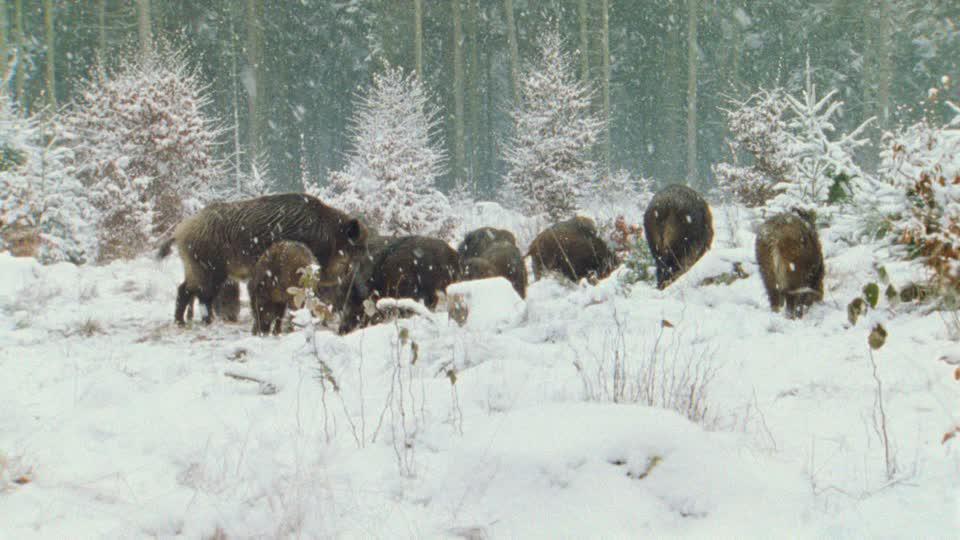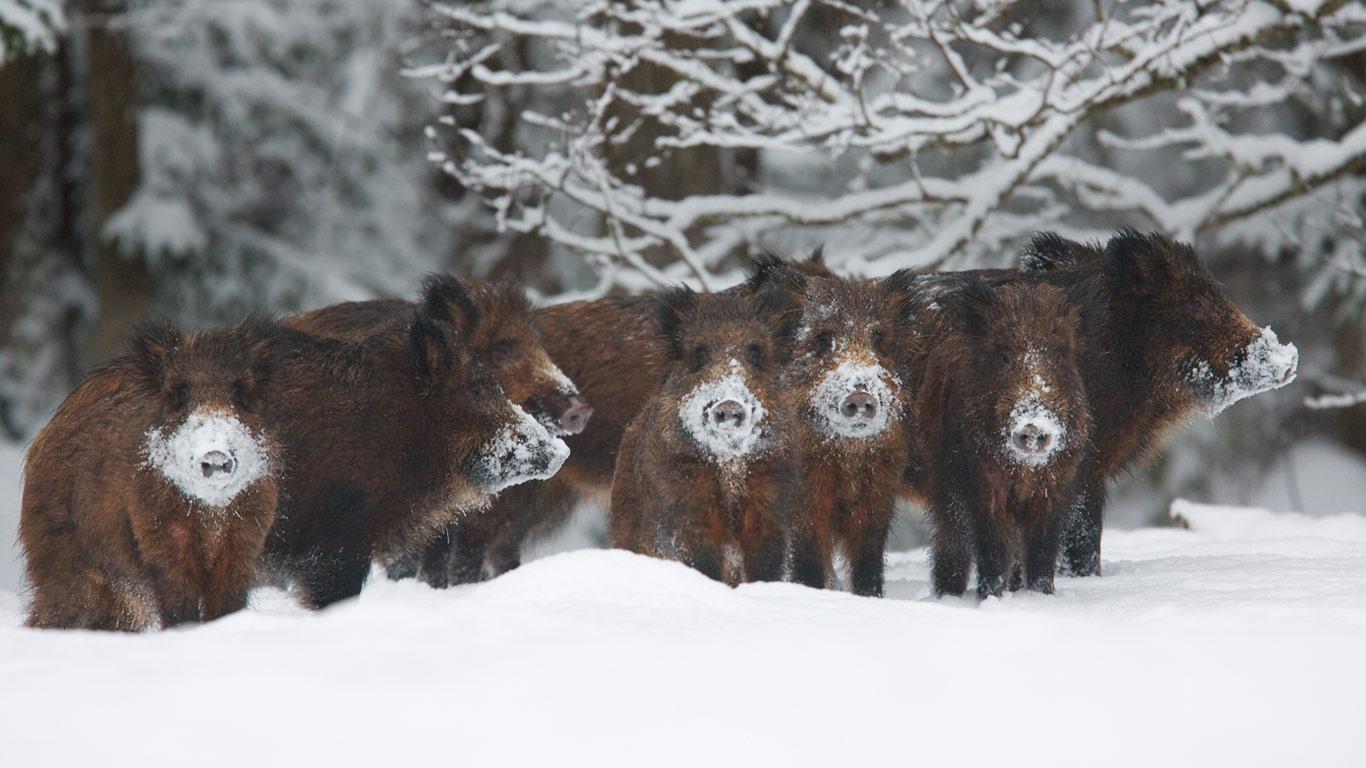The first image is the image on the left, the second image is the image on the right. For the images displayed, is the sentence "An image contains only one adult boar, which is dark and turned with its body toward the right." factually correct? Answer yes or no. No. The first image is the image on the left, the second image is the image on the right. For the images displayed, is the sentence "there is exactly one adult boar in one of the images" factually correct? Answer yes or no. No. 